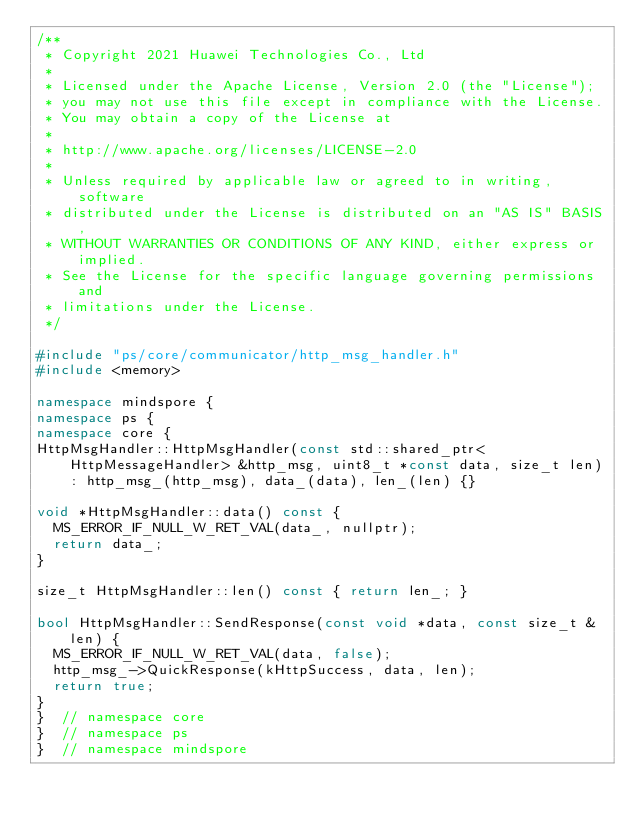<code> <loc_0><loc_0><loc_500><loc_500><_C++_>/**
 * Copyright 2021 Huawei Technologies Co., Ltd
 *
 * Licensed under the Apache License, Version 2.0 (the "License");
 * you may not use this file except in compliance with the License.
 * You may obtain a copy of the License at
 *
 * http://www.apache.org/licenses/LICENSE-2.0
 *
 * Unless required by applicable law or agreed to in writing, software
 * distributed under the License is distributed on an "AS IS" BASIS,
 * WITHOUT WARRANTIES OR CONDITIONS OF ANY KIND, either express or implied.
 * See the License for the specific language governing permissions and
 * limitations under the License.
 */

#include "ps/core/communicator/http_msg_handler.h"
#include <memory>

namespace mindspore {
namespace ps {
namespace core {
HttpMsgHandler::HttpMsgHandler(const std::shared_ptr<HttpMessageHandler> &http_msg, uint8_t *const data, size_t len)
    : http_msg_(http_msg), data_(data), len_(len) {}

void *HttpMsgHandler::data() const {
  MS_ERROR_IF_NULL_W_RET_VAL(data_, nullptr);
  return data_;
}

size_t HttpMsgHandler::len() const { return len_; }

bool HttpMsgHandler::SendResponse(const void *data, const size_t &len) {
  MS_ERROR_IF_NULL_W_RET_VAL(data, false);
  http_msg_->QuickResponse(kHttpSuccess, data, len);
  return true;
}
}  // namespace core
}  // namespace ps
}  // namespace mindspore
</code> 